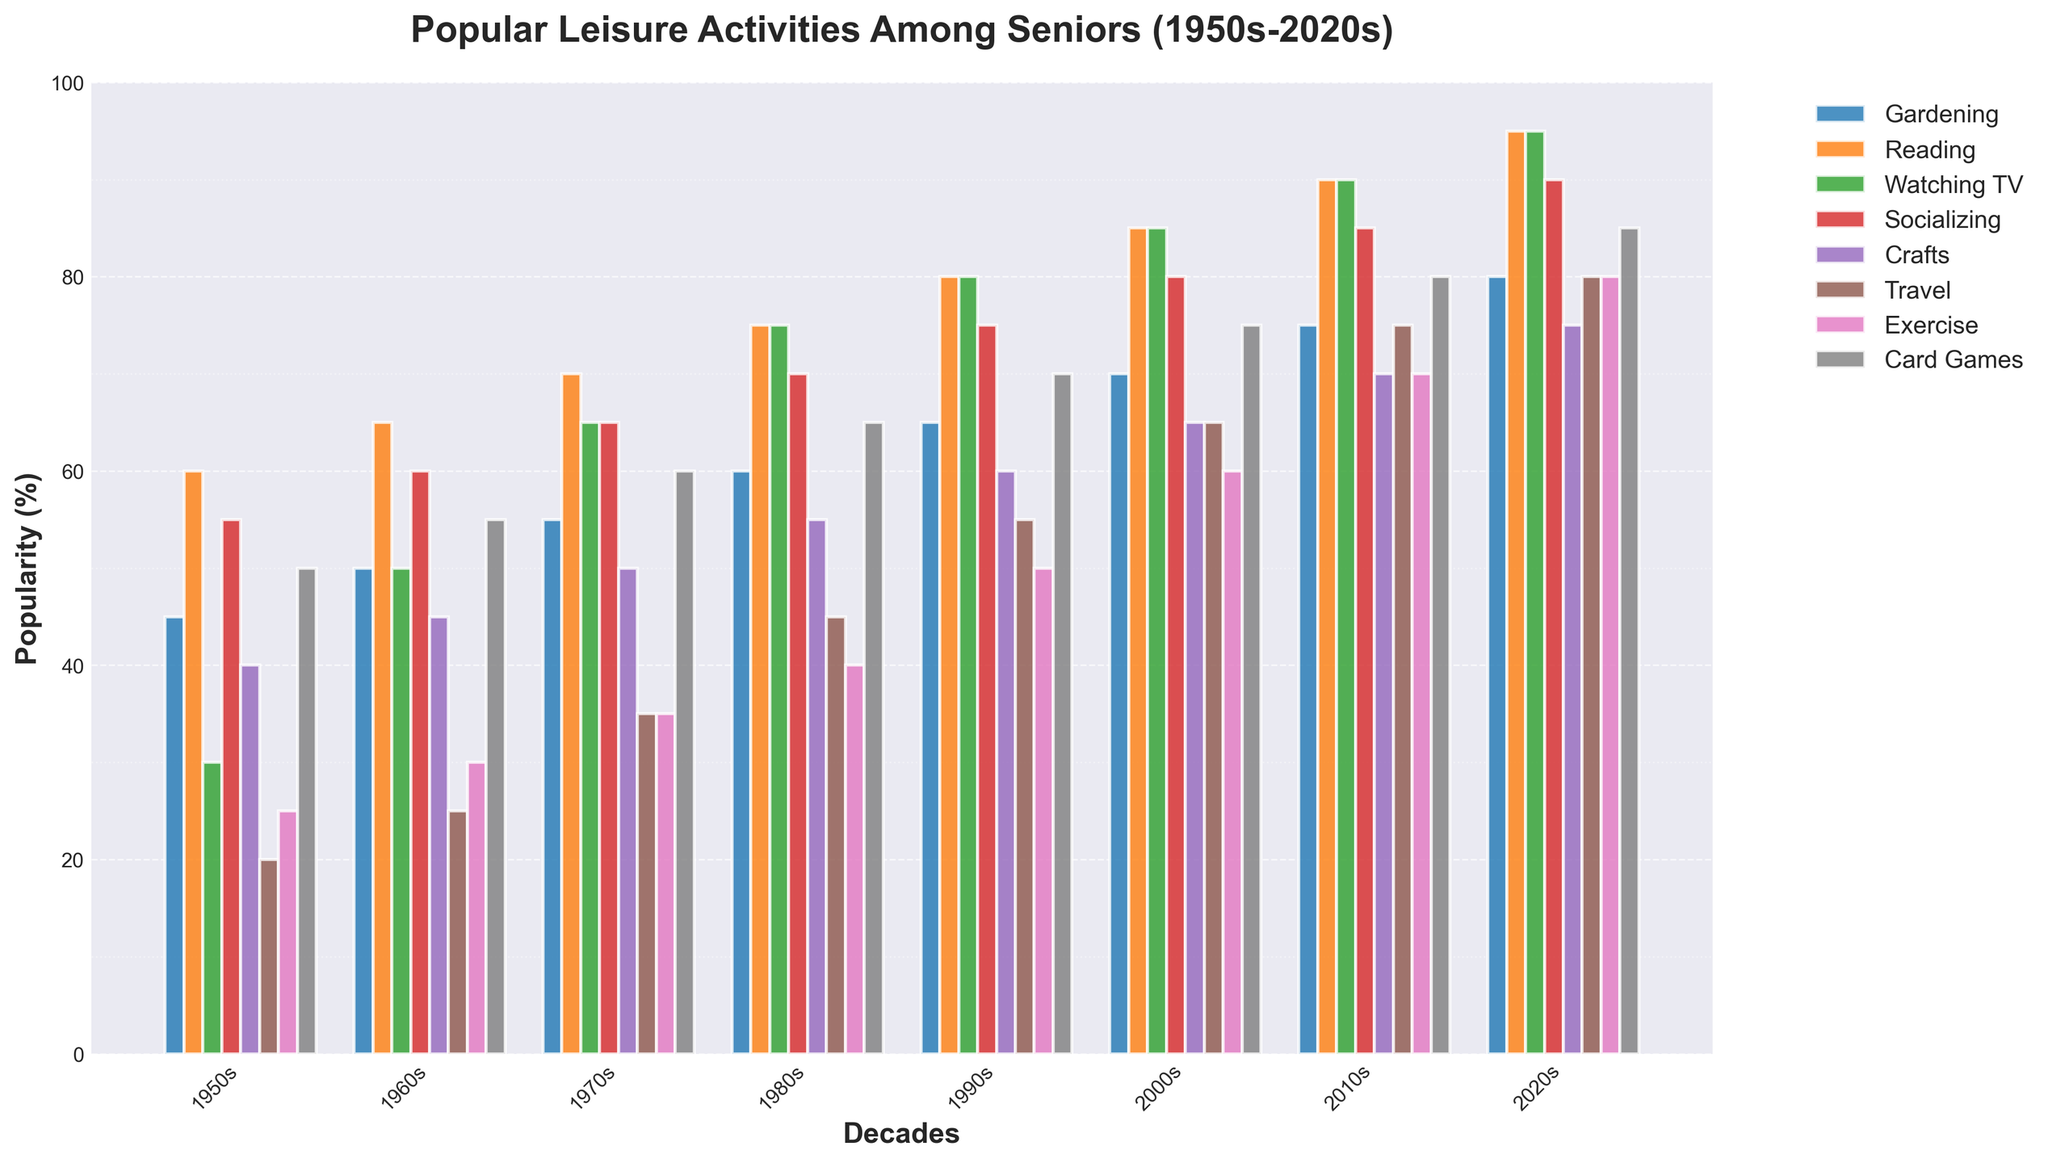What's the most popular leisure activity among seniors in the 2020s? The bar representing the 2020s shows the tallest bar for "Reading," with a value of 95%. Hence, it's the most popular.
Answer: Reading Which decade saw the greatest increase in the popularity of Traveling among seniors compared to the previous decade? Look at the "Travel" bar for each decade and calculate the difference between consecutive decades. The biggest jump is from the 1990s (55%) to the 2000s (65%), a 10% increase.
Answer: 2000s What's the average popularity of Crafting activities among seniors in the 1950s, 1960s, and 1970s? Sum the values for "Crafts" in the 1950s (40), 1960s (45), and 1970s (50) and divide by 3: (40+45+50)/3 = 45.
Answer: 45 Compare the popularity of Watching TV and Socializing in the 1980s. Which activity was more popular and by how much? In the 1980s, Watching TV is 75%, and Socializing is 70%. Watching TV was more popular by 5%.
Answer: Watching TV, 5% Which leisure activity saw a steady increase in popularity every decade from the 1950s to the 2020s? By visually inspecting the bars for each decade, "Reading" shows a steady increase from 60% in the 1950s to 95% in the 2020s.
Answer: Reading Calculate the total popularity of Exercise over all decades. Sum the percentages for Exercise from each decade: 25+30+35+40+50+60+70+80 = 390.
Answer: 390 Compare the popularity of Card Games in the 1950s and the 2020s. How much did it increase? Card Games increased from 50% in the 1950s to 85% in the 2020s. The increase is 85 - 50 = 35%.
Answer: 35% Which activity saw the least change in popularity from the 1950s to the 2020s? By finding the difference between the 1950s and the 2020s for each activity, "Card Games" changed from 50% to 85%, a change of 35%. This can be cross-verified with smaller changes among other activities if further validation is needed.
Answer: Card Games What’s the median popularity percentage for Socializing across all decades? The percentages for Socializing are: 55, 60, 65, 70, 75, 80, 85, 90. Median is the average of the 4th and 5th values: (70+75)/2 = 72.5.
Answer: 72.5 